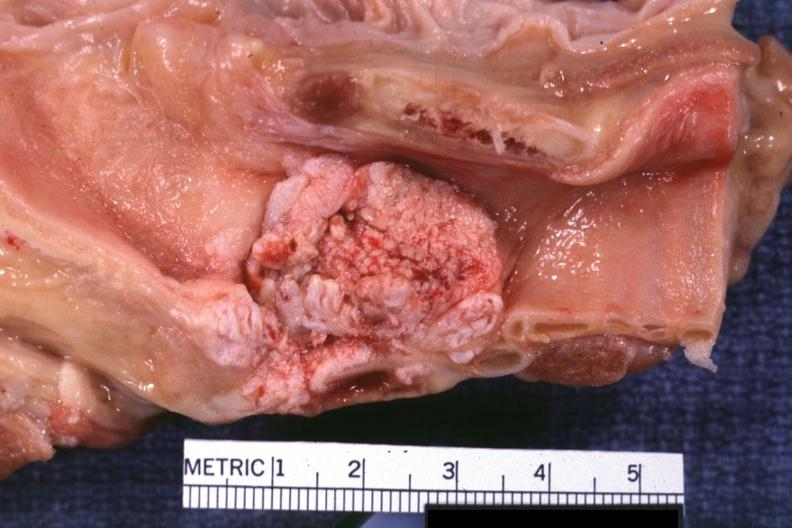what is present?
Answer the question using a single word or phrase. Carcinoma 